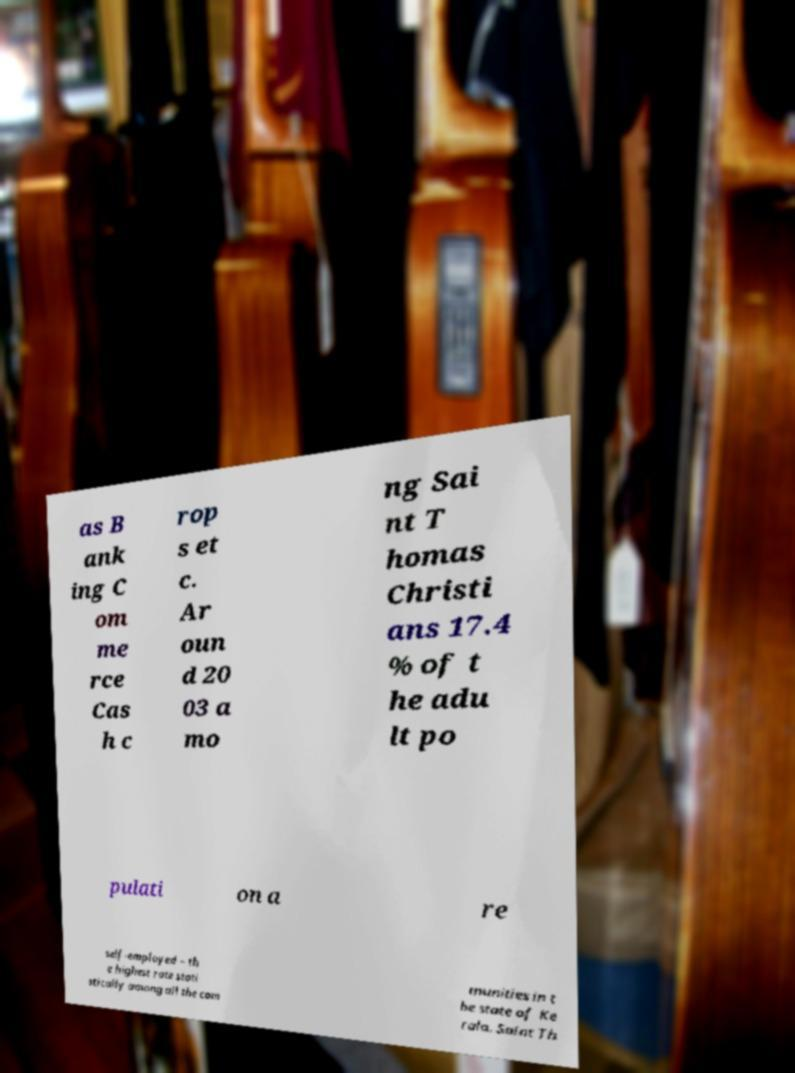Can you accurately transcribe the text from the provided image for me? as B ank ing C om me rce Cas h c rop s et c. Ar oun d 20 03 a mo ng Sai nt T homas Christi ans 17.4 % of t he adu lt po pulati on a re self-employed – th e highest rate stati stically among all the com munities in t he state of Ke rala. Saint Th 